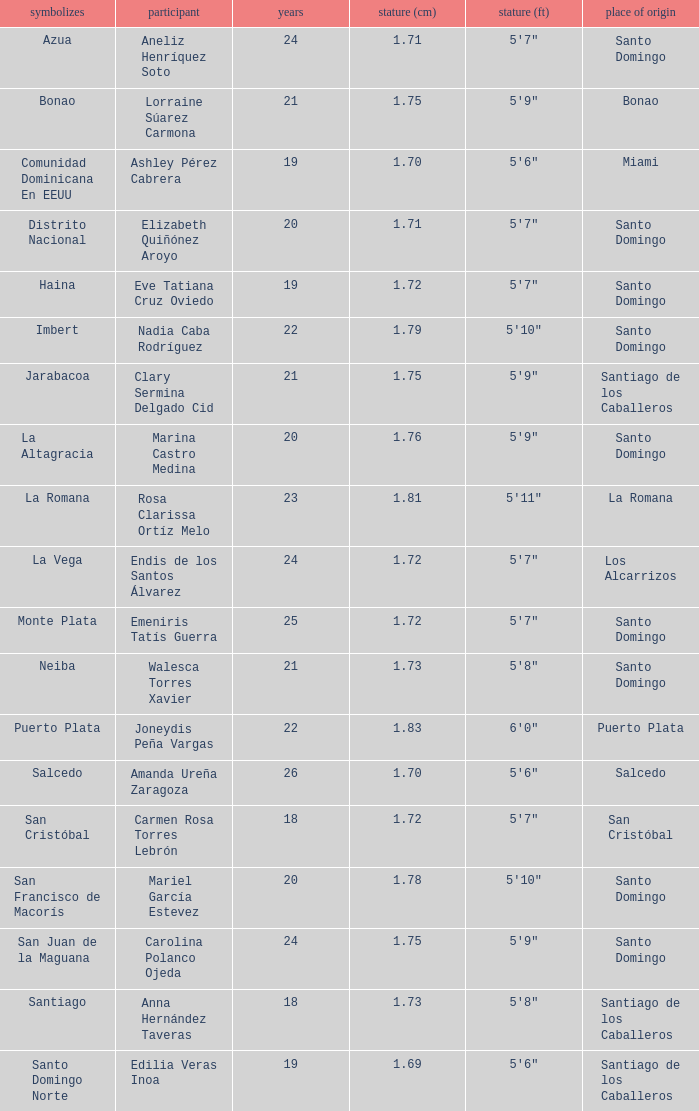Name the least age for distrito nacional 20.0. 